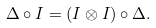<formula> <loc_0><loc_0><loc_500><loc_500>\Delta \circ I = ( I \otimes I ) \circ \Delta .</formula> 